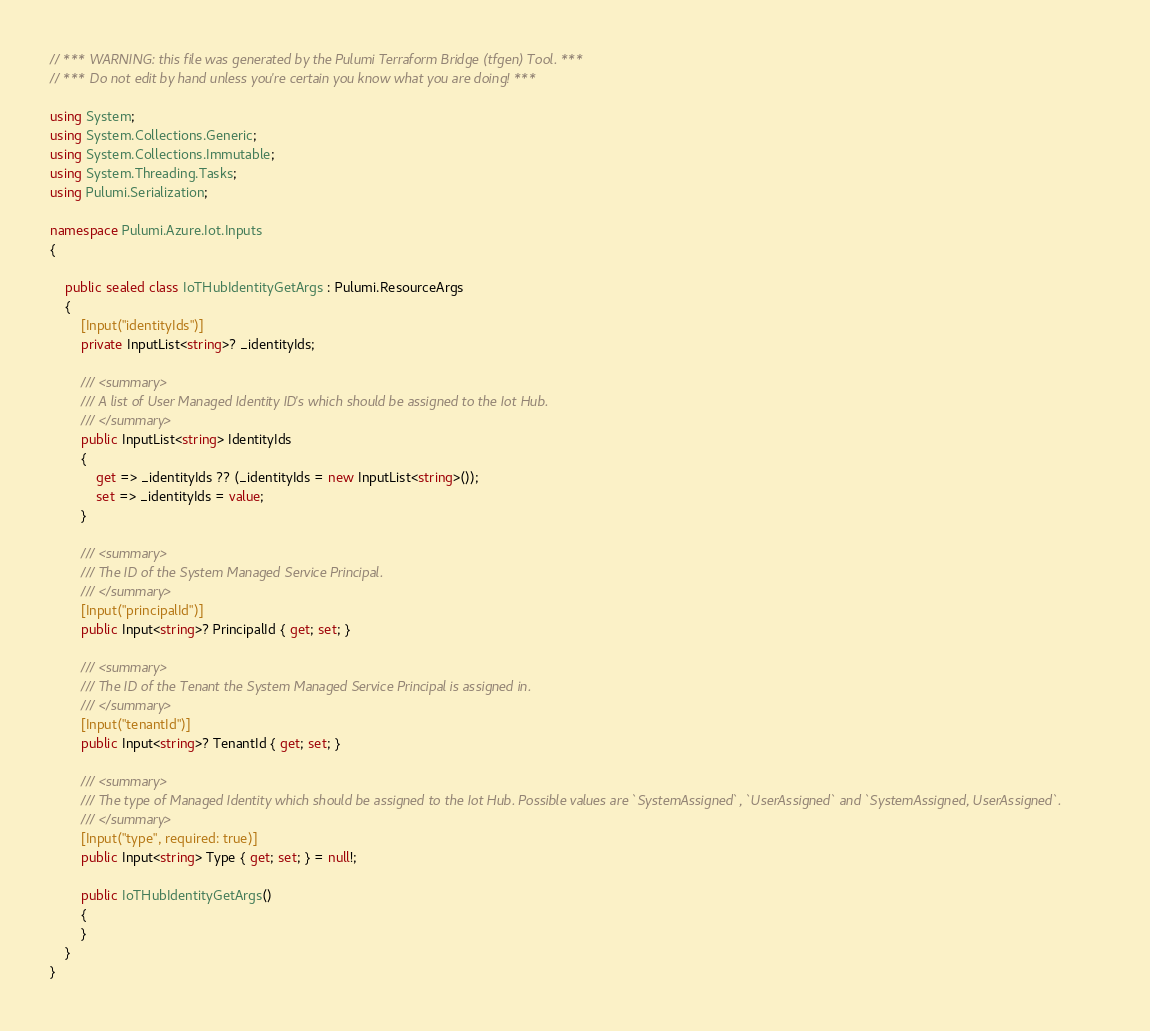Convert code to text. <code><loc_0><loc_0><loc_500><loc_500><_C#_>// *** WARNING: this file was generated by the Pulumi Terraform Bridge (tfgen) Tool. ***
// *** Do not edit by hand unless you're certain you know what you are doing! ***

using System;
using System.Collections.Generic;
using System.Collections.Immutable;
using System.Threading.Tasks;
using Pulumi.Serialization;

namespace Pulumi.Azure.Iot.Inputs
{

    public sealed class IoTHubIdentityGetArgs : Pulumi.ResourceArgs
    {
        [Input("identityIds")]
        private InputList<string>? _identityIds;

        /// <summary>
        /// A list of User Managed Identity ID's which should be assigned to the Iot Hub.
        /// </summary>
        public InputList<string> IdentityIds
        {
            get => _identityIds ?? (_identityIds = new InputList<string>());
            set => _identityIds = value;
        }

        /// <summary>
        /// The ID of the System Managed Service Principal.
        /// </summary>
        [Input("principalId")]
        public Input<string>? PrincipalId { get; set; }

        /// <summary>
        /// The ID of the Tenant the System Managed Service Principal is assigned in.
        /// </summary>
        [Input("tenantId")]
        public Input<string>? TenantId { get; set; }

        /// <summary>
        /// The type of Managed Identity which should be assigned to the Iot Hub. Possible values are `SystemAssigned`, `UserAssigned` and `SystemAssigned, UserAssigned`.
        /// </summary>
        [Input("type", required: true)]
        public Input<string> Type { get; set; } = null!;

        public IoTHubIdentityGetArgs()
        {
        }
    }
}
</code> 